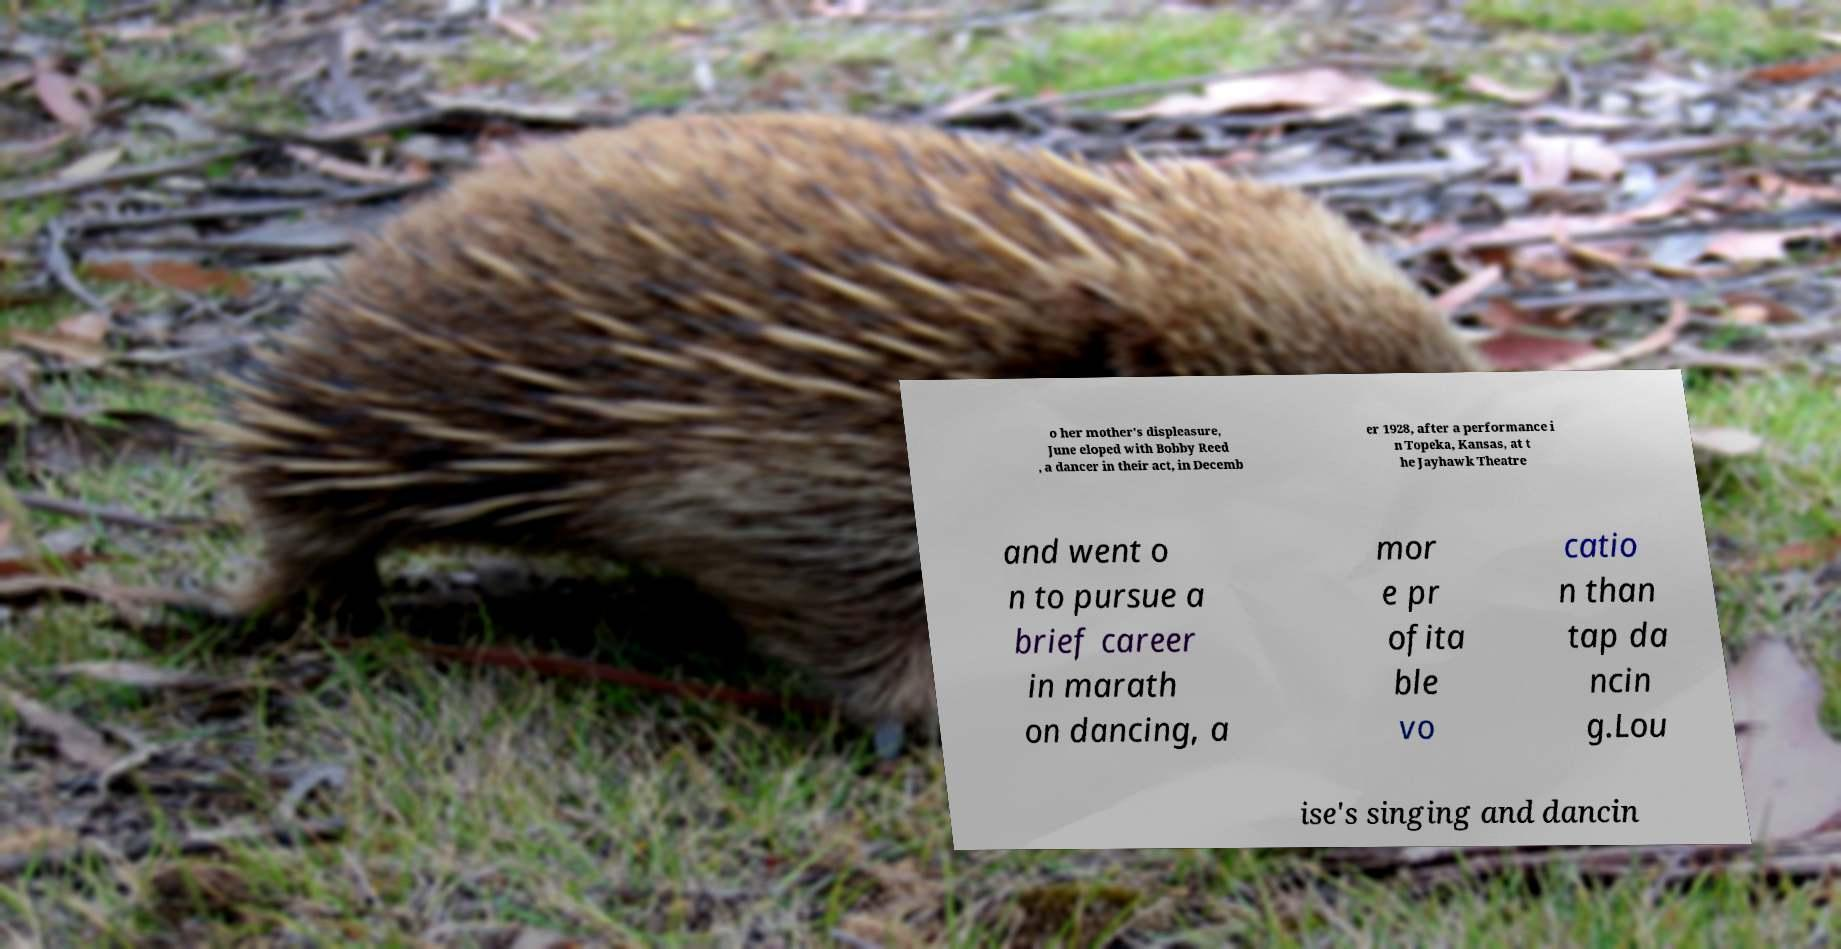There's text embedded in this image that I need extracted. Can you transcribe it verbatim? o her mother's displeasure, June eloped with Bobby Reed , a dancer in their act, in Decemb er 1928, after a performance i n Topeka, Kansas, at t he Jayhawk Theatre and went o n to pursue a brief career in marath on dancing, a mor e pr ofita ble vo catio n than tap da ncin g.Lou ise's singing and dancin 